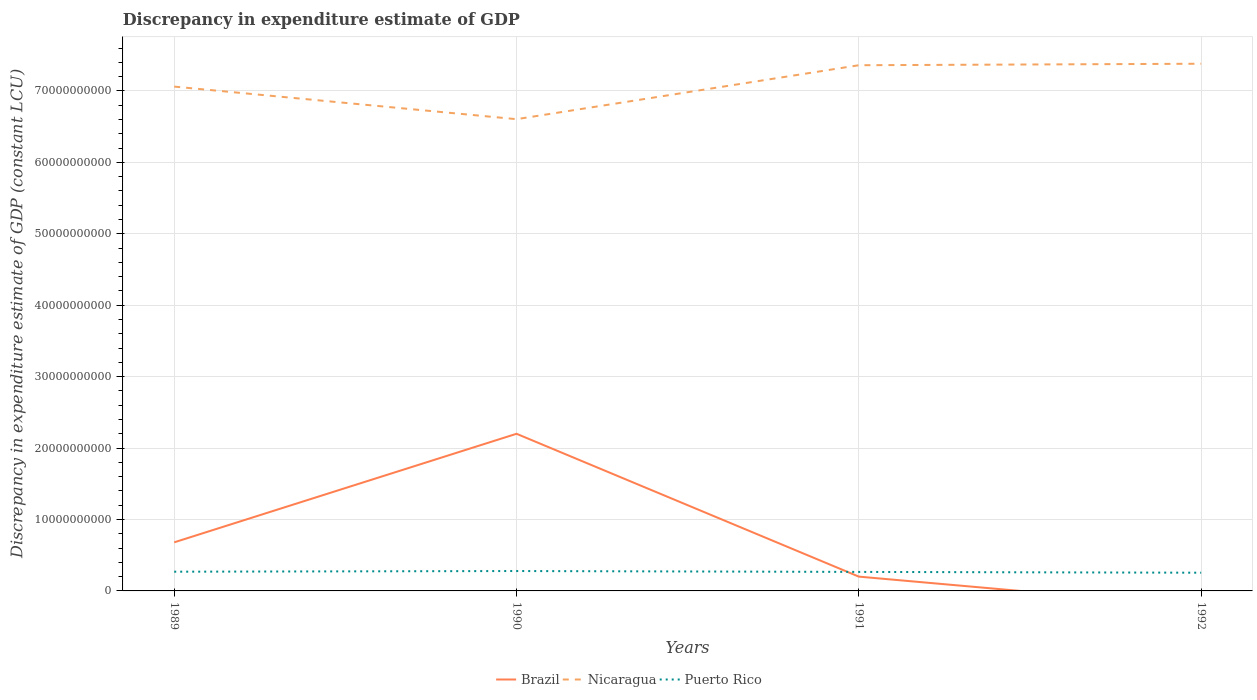Is the number of lines equal to the number of legend labels?
Offer a very short reply. No. Across all years, what is the maximum discrepancy in expenditure estimate of GDP in Nicaragua?
Provide a short and direct response. 6.60e+1. What is the total discrepancy in expenditure estimate of GDP in Nicaragua in the graph?
Provide a succinct answer. -2.99e+09. What is the difference between the highest and the second highest discrepancy in expenditure estimate of GDP in Puerto Rico?
Your answer should be very brief. 2.36e+08. What is the difference between the highest and the lowest discrepancy in expenditure estimate of GDP in Puerto Rico?
Offer a terse response. 2. Is the discrepancy in expenditure estimate of GDP in Brazil strictly greater than the discrepancy in expenditure estimate of GDP in Puerto Rico over the years?
Provide a succinct answer. No. How many lines are there?
Provide a short and direct response. 3. How many years are there in the graph?
Offer a very short reply. 4. Does the graph contain any zero values?
Ensure brevity in your answer.  Yes. How many legend labels are there?
Your answer should be very brief. 3. What is the title of the graph?
Ensure brevity in your answer.  Discrepancy in expenditure estimate of GDP. What is the label or title of the Y-axis?
Make the answer very short. Discrepancy in expenditure estimate of GDP (constant LCU). What is the Discrepancy in expenditure estimate of GDP (constant LCU) of Brazil in 1989?
Your answer should be compact. 6.80e+09. What is the Discrepancy in expenditure estimate of GDP (constant LCU) in Nicaragua in 1989?
Provide a short and direct response. 7.06e+1. What is the Discrepancy in expenditure estimate of GDP (constant LCU) in Puerto Rico in 1989?
Your answer should be very brief. 2.69e+09. What is the Discrepancy in expenditure estimate of GDP (constant LCU) in Brazil in 1990?
Your response must be concise. 2.20e+1. What is the Discrepancy in expenditure estimate of GDP (constant LCU) of Nicaragua in 1990?
Offer a very short reply. 6.60e+1. What is the Discrepancy in expenditure estimate of GDP (constant LCU) of Puerto Rico in 1990?
Your response must be concise. 2.78e+09. What is the Discrepancy in expenditure estimate of GDP (constant LCU) in Brazil in 1991?
Your answer should be very brief. 2.00e+09. What is the Discrepancy in expenditure estimate of GDP (constant LCU) of Nicaragua in 1991?
Your response must be concise. 7.36e+1. What is the Discrepancy in expenditure estimate of GDP (constant LCU) of Puerto Rico in 1991?
Provide a short and direct response. 2.66e+09. What is the Discrepancy in expenditure estimate of GDP (constant LCU) of Brazil in 1992?
Give a very brief answer. 0. What is the Discrepancy in expenditure estimate of GDP (constant LCU) of Nicaragua in 1992?
Make the answer very short. 7.38e+1. What is the Discrepancy in expenditure estimate of GDP (constant LCU) in Puerto Rico in 1992?
Offer a very short reply. 2.55e+09. Across all years, what is the maximum Discrepancy in expenditure estimate of GDP (constant LCU) of Brazil?
Keep it short and to the point. 2.20e+1. Across all years, what is the maximum Discrepancy in expenditure estimate of GDP (constant LCU) of Nicaragua?
Make the answer very short. 7.38e+1. Across all years, what is the maximum Discrepancy in expenditure estimate of GDP (constant LCU) of Puerto Rico?
Your answer should be very brief. 2.78e+09. Across all years, what is the minimum Discrepancy in expenditure estimate of GDP (constant LCU) in Brazil?
Offer a terse response. 0. Across all years, what is the minimum Discrepancy in expenditure estimate of GDP (constant LCU) of Nicaragua?
Ensure brevity in your answer.  6.60e+1. Across all years, what is the minimum Discrepancy in expenditure estimate of GDP (constant LCU) of Puerto Rico?
Provide a succinct answer. 2.55e+09. What is the total Discrepancy in expenditure estimate of GDP (constant LCU) in Brazil in the graph?
Offer a very short reply. 3.08e+1. What is the total Discrepancy in expenditure estimate of GDP (constant LCU) in Nicaragua in the graph?
Provide a succinct answer. 2.84e+11. What is the total Discrepancy in expenditure estimate of GDP (constant LCU) in Puerto Rico in the graph?
Provide a succinct answer. 1.07e+1. What is the difference between the Discrepancy in expenditure estimate of GDP (constant LCU) of Brazil in 1989 and that in 1990?
Your answer should be compact. -1.52e+1. What is the difference between the Discrepancy in expenditure estimate of GDP (constant LCU) of Nicaragua in 1989 and that in 1990?
Offer a very short reply. 4.56e+09. What is the difference between the Discrepancy in expenditure estimate of GDP (constant LCU) in Puerto Rico in 1989 and that in 1990?
Make the answer very short. -9.37e+07. What is the difference between the Discrepancy in expenditure estimate of GDP (constant LCU) of Brazil in 1989 and that in 1991?
Offer a terse response. 4.80e+09. What is the difference between the Discrepancy in expenditure estimate of GDP (constant LCU) in Nicaragua in 1989 and that in 1991?
Your answer should be very brief. -2.99e+09. What is the difference between the Discrepancy in expenditure estimate of GDP (constant LCU) in Puerto Rico in 1989 and that in 1991?
Offer a very short reply. 3.03e+07. What is the difference between the Discrepancy in expenditure estimate of GDP (constant LCU) of Nicaragua in 1989 and that in 1992?
Give a very brief answer. -3.20e+09. What is the difference between the Discrepancy in expenditure estimate of GDP (constant LCU) of Puerto Rico in 1989 and that in 1992?
Your answer should be very brief. 1.42e+08. What is the difference between the Discrepancy in expenditure estimate of GDP (constant LCU) of Brazil in 1990 and that in 1991?
Offer a terse response. 2.00e+1. What is the difference between the Discrepancy in expenditure estimate of GDP (constant LCU) of Nicaragua in 1990 and that in 1991?
Give a very brief answer. -7.55e+09. What is the difference between the Discrepancy in expenditure estimate of GDP (constant LCU) of Puerto Rico in 1990 and that in 1991?
Provide a short and direct response. 1.24e+08. What is the difference between the Discrepancy in expenditure estimate of GDP (constant LCU) of Nicaragua in 1990 and that in 1992?
Provide a short and direct response. -7.76e+09. What is the difference between the Discrepancy in expenditure estimate of GDP (constant LCU) in Puerto Rico in 1990 and that in 1992?
Your answer should be compact. 2.36e+08. What is the difference between the Discrepancy in expenditure estimate of GDP (constant LCU) in Nicaragua in 1991 and that in 1992?
Your answer should be very brief. -2.09e+08. What is the difference between the Discrepancy in expenditure estimate of GDP (constant LCU) in Puerto Rico in 1991 and that in 1992?
Keep it short and to the point. 1.12e+08. What is the difference between the Discrepancy in expenditure estimate of GDP (constant LCU) of Brazil in 1989 and the Discrepancy in expenditure estimate of GDP (constant LCU) of Nicaragua in 1990?
Offer a very short reply. -5.92e+1. What is the difference between the Discrepancy in expenditure estimate of GDP (constant LCU) of Brazil in 1989 and the Discrepancy in expenditure estimate of GDP (constant LCU) of Puerto Rico in 1990?
Give a very brief answer. 4.02e+09. What is the difference between the Discrepancy in expenditure estimate of GDP (constant LCU) of Nicaragua in 1989 and the Discrepancy in expenditure estimate of GDP (constant LCU) of Puerto Rico in 1990?
Offer a very short reply. 6.78e+1. What is the difference between the Discrepancy in expenditure estimate of GDP (constant LCU) in Brazil in 1989 and the Discrepancy in expenditure estimate of GDP (constant LCU) in Nicaragua in 1991?
Offer a terse response. -6.68e+1. What is the difference between the Discrepancy in expenditure estimate of GDP (constant LCU) of Brazil in 1989 and the Discrepancy in expenditure estimate of GDP (constant LCU) of Puerto Rico in 1991?
Provide a short and direct response. 4.14e+09. What is the difference between the Discrepancy in expenditure estimate of GDP (constant LCU) in Nicaragua in 1989 and the Discrepancy in expenditure estimate of GDP (constant LCU) in Puerto Rico in 1991?
Your response must be concise. 6.79e+1. What is the difference between the Discrepancy in expenditure estimate of GDP (constant LCU) of Brazil in 1989 and the Discrepancy in expenditure estimate of GDP (constant LCU) of Nicaragua in 1992?
Make the answer very short. -6.70e+1. What is the difference between the Discrepancy in expenditure estimate of GDP (constant LCU) of Brazil in 1989 and the Discrepancy in expenditure estimate of GDP (constant LCU) of Puerto Rico in 1992?
Provide a succinct answer. 4.25e+09. What is the difference between the Discrepancy in expenditure estimate of GDP (constant LCU) in Nicaragua in 1989 and the Discrepancy in expenditure estimate of GDP (constant LCU) in Puerto Rico in 1992?
Provide a succinct answer. 6.80e+1. What is the difference between the Discrepancy in expenditure estimate of GDP (constant LCU) in Brazil in 1990 and the Discrepancy in expenditure estimate of GDP (constant LCU) in Nicaragua in 1991?
Your response must be concise. -5.16e+1. What is the difference between the Discrepancy in expenditure estimate of GDP (constant LCU) in Brazil in 1990 and the Discrepancy in expenditure estimate of GDP (constant LCU) in Puerto Rico in 1991?
Keep it short and to the point. 1.93e+1. What is the difference between the Discrepancy in expenditure estimate of GDP (constant LCU) in Nicaragua in 1990 and the Discrepancy in expenditure estimate of GDP (constant LCU) in Puerto Rico in 1991?
Your response must be concise. 6.34e+1. What is the difference between the Discrepancy in expenditure estimate of GDP (constant LCU) of Brazil in 1990 and the Discrepancy in expenditure estimate of GDP (constant LCU) of Nicaragua in 1992?
Give a very brief answer. -5.18e+1. What is the difference between the Discrepancy in expenditure estimate of GDP (constant LCU) in Brazil in 1990 and the Discrepancy in expenditure estimate of GDP (constant LCU) in Puerto Rico in 1992?
Your answer should be compact. 1.94e+1. What is the difference between the Discrepancy in expenditure estimate of GDP (constant LCU) of Nicaragua in 1990 and the Discrepancy in expenditure estimate of GDP (constant LCU) of Puerto Rico in 1992?
Offer a very short reply. 6.35e+1. What is the difference between the Discrepancy in expenditure estimate of GDP (constant LCU) of Brazil in 1991 and the Discrepancy in expenditure estimate of GDP (constant LCU) of Nicaragua in 1992?
Provide a short and direct response. -7.18e+1. What is the difference between the Discrepancy in expenditure estimate of GDP (constant LCU) in Brazil in 1991 and the Discrepancy in expenditure estimate of GDP (constant LCU) in Puerto Rico in 1992?
Offer a terse response. -5.48e+08. What is the difference between the Discrepancy in expenditure estimate of GDP (constant LCU) of Nicaragua in 1991 and the Discrepancy in expenditure estimate of GDP (constant LCU) of Puerto Rico in 1992?
Ensure brevity in your answer.  7.10e+1. What is the average Discrepancy in expenditure estimate of GDP (constant LCU) in Brazil per year?
Your response must be concise. 7.70e+09. What is the average Discrepancy in expenditure estimate of GDP (constant LCU) of Nicaragua per year?
Provide a succinct answer. 7.10e+1. What is the average Discrepancy in expenditure estimate of GDP (constant LCU) of Puerto Rico per year?
Provide a succinct answer. 2.67e+09. In the year 1989, what is the difference between the Discrepancy in expenditure estimate of GDP (constant LCU) in Brazil and Discrepancy in expenditure estimate of GDP (constant LCU) in Nicaragua?
Provide a short and direct response. -6.38e+1. In the year 1989, what is the difference between the Discrepancy in expenditure estimate of GDP (constant LCU) in Brazil and Discrepancy in expenditure estimate of GDP (constant LCU) in Puerto Rico?
Your answer should be compact. 4.11e+09. In the year 1989, what is the difference between the Discrepancy in expenditure estimate of GDP (constant LCU) in Nicaragua and Discrepancy in expenditure estimate of GDP (constant LCU) in Puerto Rico?
Your response must be concise. 6.79e+1. In the year 1990, what is the difference between the Discrepancy in expenditure estimate of GDP (constant LCU) in Brazil and Discrepancy in expenditure estimate of GDP (constant LCU) in Nicaragua?
Your response must be concise. -4.40e+1. In the year 1990, what is the difference between the Discrepancy in expenditure estimate of GDP (constant LCU) of Brazil and Discrepancy in expenditure estimate of GDP (constant LCU) of Puerto Rico?
Provide a succinct answer. 1.92e+1. In the year 1990, what is the difference between the Discrepancy in expenditure estimate of GDP (constant LCU) of Nicaragua and Discrepancy in expenditure estimate of GDP (constant LCU) of Puerto Rico?
Make the answer very short. 6.33e+1. In the year 1991, what is the difference between the Discrepancy in expenditure estimate of GDP (constant LCU) of Brazil and Discrepancy in expenditure estimate of GDP (constant LCU) of Nicaragua?
Offer a terse response. -7.16e+1. In the year 1991, what is the difference between the Discrepancy in expenditure estimate of GDP (constant LCU) in Brazil and Discrepancy in expenditure estimate of GDP (constant LCU) in Puerto Rico?
Your answer should be very brief. -6.60e+08. In the year 1991, what is the difference between the Discrepancy in expenditure estimate of GDP (constant LCU) in Nicaragua and Discrepancy in expenditure estimate of GDP (constant LCU) in Puerto Rico?
Your answer should be very brief. 7.09e+1. In the year 1992, what is the difference between the Discrepancy in expenditure estimate of GDP (constant LCU) of Nicaragua and Discrepancy in expenditure estimate of GDP (constant LCU) of Puerto Rico?
Give a very brief answer. 7.12e+1. What is the ratio of the Discrepancy in expenditure estimate of GDP (constant LCU) of Brazil in 1989 to that in 1990?
Your answer should be compact. 0.31. What is the ratio of the Discrepancy in expenditure estimate of GDP (constant LCU) in Nicaragua in 1989 to that in 1990?
Provide a short and direct response. 1.07. What is the ratio of the Discrepancy in expenditure estimate of GDP (constant LCU) of Puerto Rico in 1989 to that in 1990?
Provide a succinct answer. 0.97. What is the ratio of the Discrepancy in expenditure estimate of GDP (constant LCU) of Brazil in 1989 to that in 1991?
Ensure brevity in your answer.  3.4. What is the ratio of the Discrepancy in expenditure estimate of GDP (constant LCU) in Nicaragua in 1989 to that in 1991?
Offer a terse response. 0.96. What is the ratio of the Discrepancy in expenditure estimate of GDP (constant LCU) in Puerto Rico in 1989 to that in 1991?
Keep it short and to the point. 1.01. What is the ratio of the Discrepancy in expenditure estimate of GDP (constant LCU) of Nicaragua in 1989 to that in 1992?
Your answer should be compact. 0.96. What is the ratio of the Discrepancy in expenditure estimate of GDP (constant LCU) in Puerto Rico in 1989 to that in 1992?
Offer a terse response. 1.06. What is the ratio of the Discrepancy in expenditure estimate of GDP (constant LCU) in Brazil in 1990 to that in 1991?
Your answer should be very brief. 10.99. What is the ratio of the Discrepancy in expenditure estimate of GDP (constant LCU) in Nicaragua in 1990 to that in 1991?
Give a very brief answer. 0.9. What is the ratio of the Discrepancy in expenditure estimate of GDP (constant LCU) in Puerto Rico in 1990 to that in 1991?
Ensure brevity in your answer.  1.05. What is the ratio of the Discrepancy in expenditure estimate of GDP (constant LCU) of Nicaragua in 1990 to that in 1992?
Provide a short and direct response. 0.89. What is the ratio of the Discrepancy in expenditure estimate of GDP (constant LCU) of Puerto Rico in 1990 to that in 1992?
Your answer should be compact. 1.09. What is the ratio of the Discrepancy in expenditure estimate of GDP (constant LCU) in Nicaragua in 1991 to that in 1992?
Make the answer very short. 1. What is the ratio of the Discrepancy in expenditure estimate of GDP (constant LCU) in Puerto Rico in 1991 to that in 1992?
Make the answer very short. 1.04. What is the difference between the highest and the second highest Discrepancy in expenditure estimate of GDP (constant LCU) in Brazil?
Your answer should be compact. 1.52e+1. What is the difference between the highest and the second highest Discrepancy in expenditure estimate of GDP (constant LCU) in Nicaragua?
Ensure brevity in your answer.  2.09e+08. What is the difference between the highest and the second highest Discrepancy in expenditure estimate of GDP (constant LCU) in Puerto Rico?
Your response must be concise. 9.37e+07. What is the difference between the highest and the lowest Discrepancy in expenditure estimate of GDP (constant LCU) in Brazil?
Your answer should be compact. 2.20e+1. What is the difference between the highest and the lowest Discrepancy in expenditure estimate of GDP (constant LCU) in Nicaragua?
Keep it short and to the point. 7.76e+09. What is the difference between the highest and the lowest Discrepancy in expenditure estimate of GDP (constant LCU) in Puerto Rico?
Your answer should be very brief. 2.36e+08. 